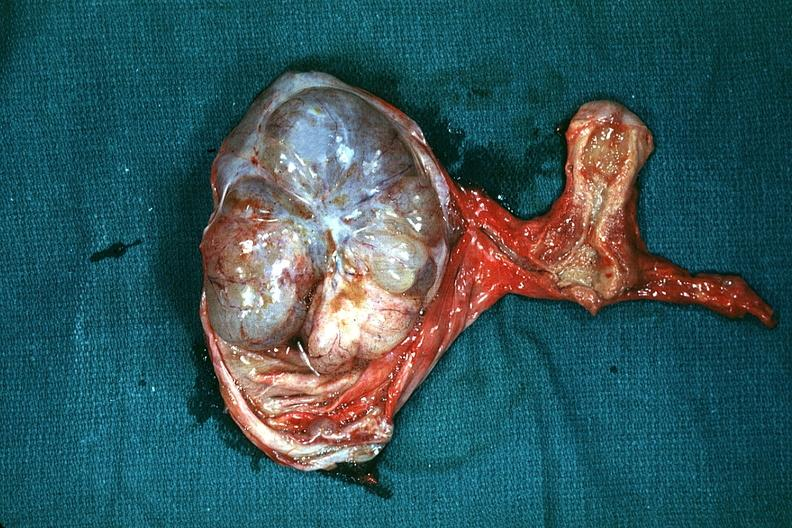how is the excellent uterus in picture and thus illustrates the very large size of the tumor?
Answer the question using a single word or phrase. Ovarian 